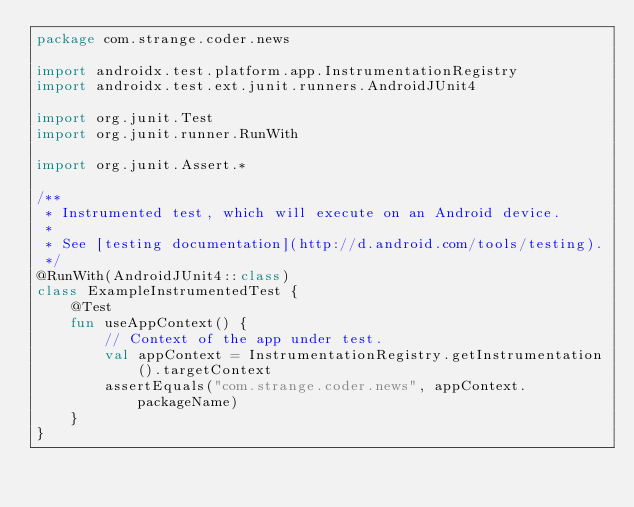<code> <loc_0><loc_0><loc_500><loc_500><_Kotlin_>package com.strange.coder.news

import androidx.test.platform.app.InstrumentationRegistry
import androidx.test.ext.junit.runners.AndroidJUnit4

import org.junit.Test
import org.junit.runner.RunWith

import org.junit.Assert.*

/**
 * Instrumented test, which will execute on an Android device.
 *
 * See [testing documentation](http://d.android.com/tools/testing).
 */
@RunWith(AndroidJUnit4::class)
class ExampleInstrumentedTest {
    @Test
    fun useAppContext() {
        // Context of the app under test.
        val appContext = InstrumentationRegistry.getInstrumentation().targetContext
        assertEquals("com.strange.coder.news", appContext.packageName)
    }
}</code> 